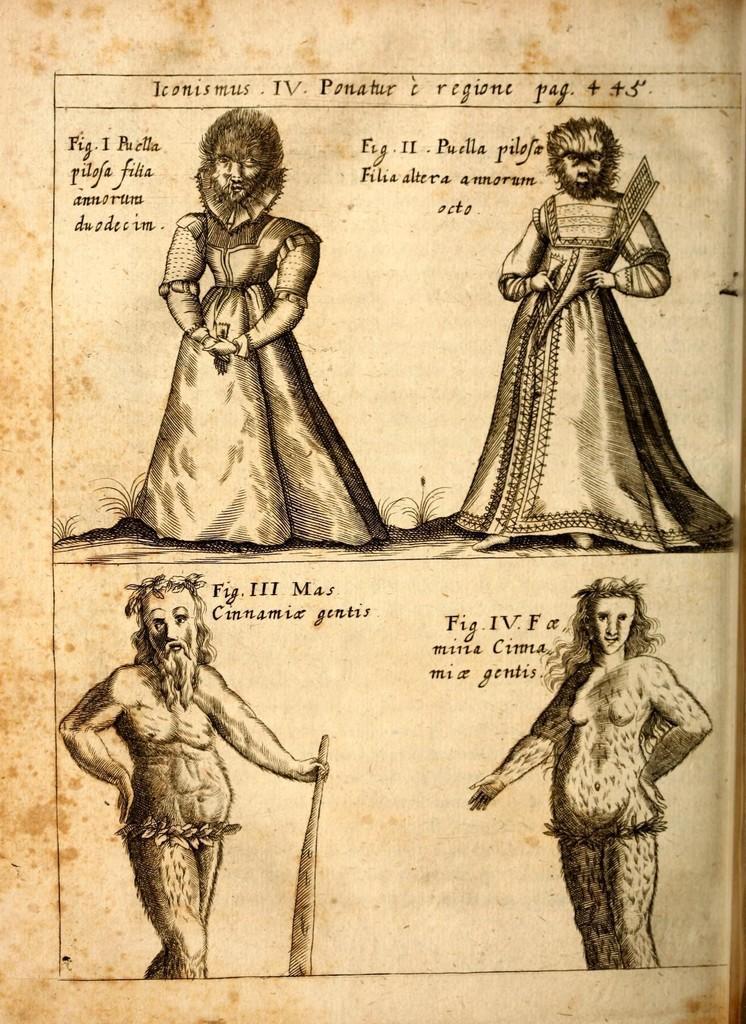Can you describe this image briefly? In this image there is a paper. We can see diagrams and text on the paper. 